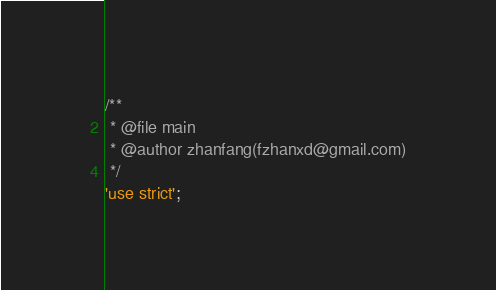Convert code to text. <code><loc_0><loc_0><loc_500><loc_500><_JavaScript_>/**
 * @file main
 * @author zhanfang(fzhanxd@gmail.com)
 */
'use strict';
</code> 